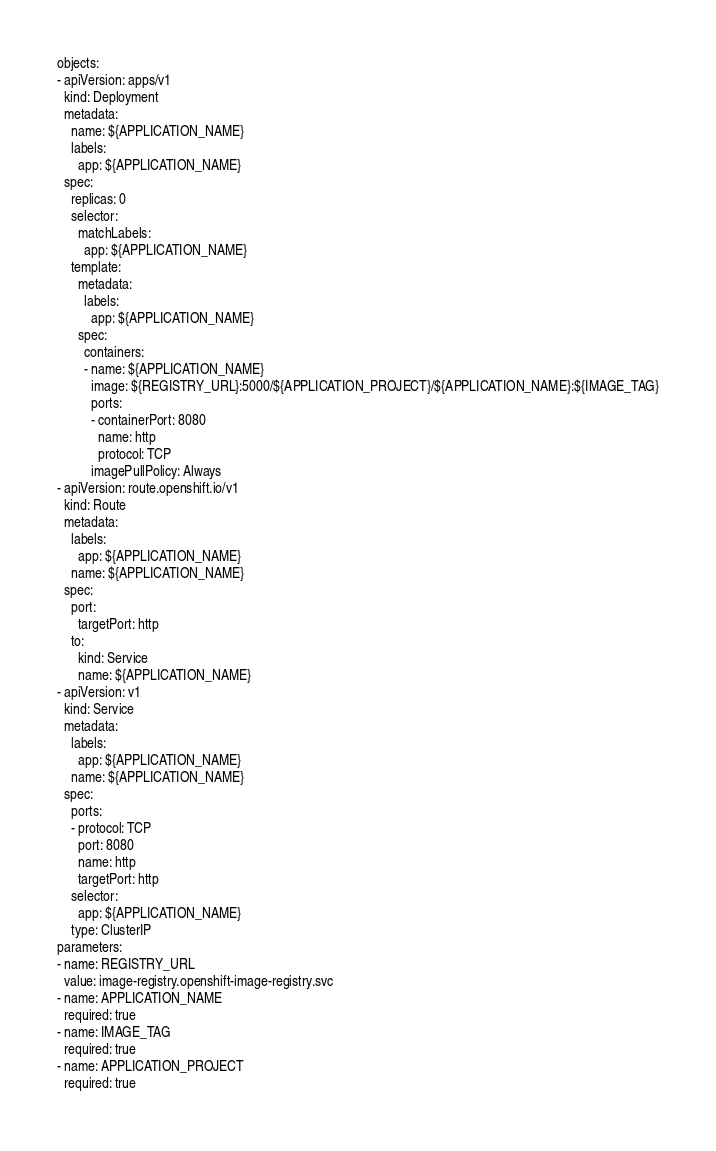<code> <loc_0><loc_0><loc_500><loc_500><_YAML_>objects:
- apiVersion: apps/v1
  kind: Deployment
  metadata:
    name: ${APPLICATION_NAME}
    labels:
      app: ${APPLICATION_NAME}
  spec:
    replicas: 0
    selector:
      matchLabels:
        app: ${APPLICATION_NAME}
    template:
      metadata:
        labels:
          app: ${APPLICATION_NAME}
      spec:
        containers:
        - name: ${APPLICATION_NAME}
          image: ${REGISTRY_URL}:5000/${APPLICATION_PROJECT}/${APPLICATION_NAME}:${IMAGE_TAG}
          ports:
          - containerPort: 8080
            name: http
            protocol: TCP
          imagePullPolicy: Always
- apiVersion: route.openshift.io/v1
  kind: Route
  metadata:
    labels:
      app: ${APPLICATION_NAME}
    name: ${APPLICATION_NAME}
  spec:
    port:
      targetPort: http
    to:
      kind: Service
      name: ${APPLICATION_NAME}
- apiVersion: v1
  kind: Service
  metadata:
    labels:
      app: ${APPLICATION_NAME}
    name: ${APPLICATION_NAME}
  spec:
    ports:
    - protocol: TCP
      port: 8080
      name: http
      targetPort: http
    selector:
      app: ${APPLICATION_NAME}
    type: ClusterIP
parameters:
- name: REGISTRY_URL
  value: image-registry.openshift-image-registry.svc
- name: APPLICATION_NAME
  required: true
- name: IMAGE_TAG
  required: true
- name: APPLICATION_PROJECT
  required: true
</code> 